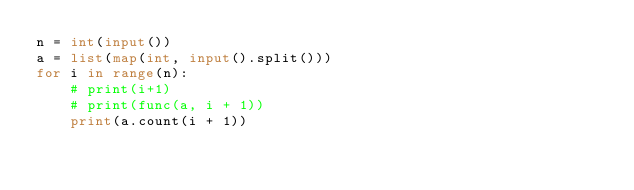<code> <loc_0><loc_0><loc_500><loc_500><_Python_>n = int(input())
a = list(map(int, input().split()))
for i in range(n):
    # print(i+1)
    # print(func(a, i + 1))
    print(a.count(i + 1))
</code> 